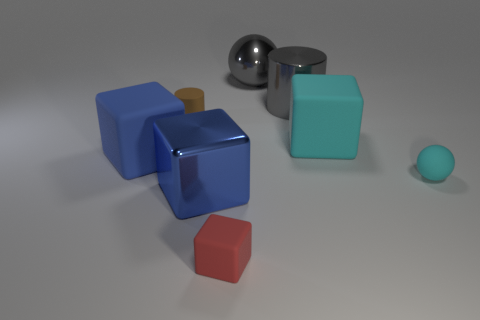The tiny cyan rubber thing is what shape?
Offer a terse response. Sphere. Are the sphere behind the small rubber cylinder and the cylinder on the right side of the small cube made of the same material?
Provide a short and direct response. Yes. How many big cylinders have the same color as the large shiny sphere?
Keep it short and to the point. 1. There is a large metallic thing that is behind the tiny ball and in front of the big sphere; what is its shape?
Make the answer very short. Cylinder. What color is the rubber object that is both on the left side of the tiny red block and behind the blue matte block?
Offer a very short reply. Brown. Are there more metallic cylinders behind the big cyan matte object than big metal blocks that are behind the big gray cylinder?
Ensure brevity in your answer.  Yes. There is a matte block to the left of the small red block; what color is it?
Provide a succinct answer. Blue. There is a shiny thing to the left of the red object; is it the same shape as the tiny thing left of the small red thing?
Make the answer very short. No. Are there any cyan metallic cubes that have the same size as the metallic ball?
Offer a very short reply. No. There is a large blue object in front of the blue matte thing; what is its material?
Keep it short and to the point. Metal. 